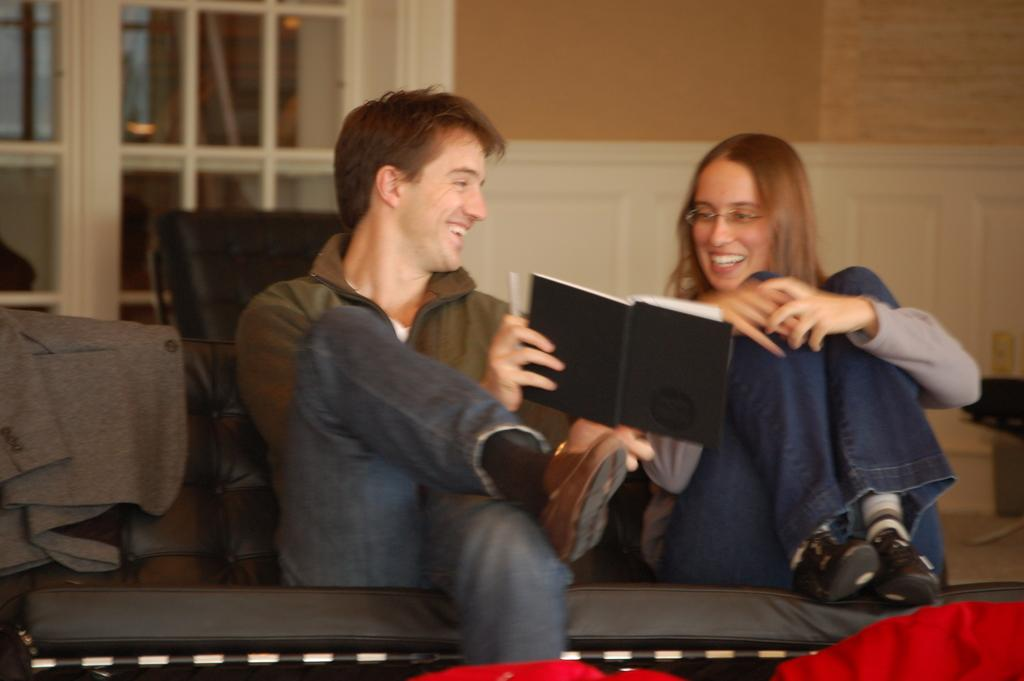How many people are in the image? There are two people in the image, a man and a woman. What is the man in the image holding? The man is holding a book in the image. What is the position of the man holding the book? The man holding the book is sitting. What type of drum can be heard in the background of the image? There is no drum or sound present in the image; it is a still image of a man holding a book and a woman. 